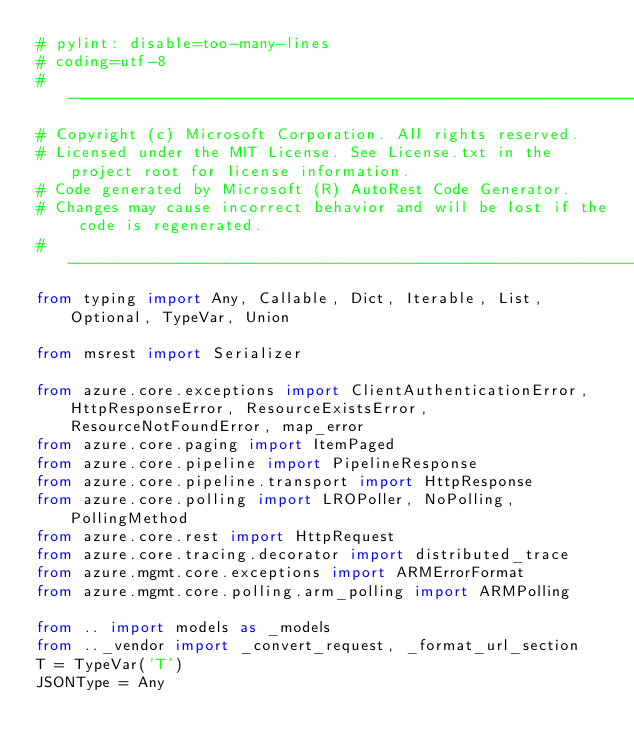<code> <loc_0><loc_0><loc_500><loc_500><_Python_># pylint: disable=too-many-lines
# coding=utf-8
# --------------------------------------------------------------------------
# Copyright (c) Microsoft Corporation. All rights reserved.
# Licensed under the MIT License. See License.txt in the project root for license information.
# Code generated by Microsoft (R) AutoRest Code Generator.
# Changes may cause incorrect behavior and will be lost if the code is regenerated.
# --------------------------------------------------------------------------
from typing import Any, Callable, Dict, Iterable, List, Optional, TypeVar, Union

from msrest import Serializer

from azure.core.exceptions import ClientAuthenticationError, HttpResponseError, ResourceExistsError, ResourceNotFoundError, map_error
from azure.core.paging import ItemPaged
from azure.core.pipeline import PipelineResponse
from azure.core.pipeline.transport import HttpResponse
from azure.core.polling import LROPoller, NoPolling, PollingMethod
from azure.core.rest import HttpRequest
from azure.core.tracing.decorator import distributed_trace
from azure.mgmt.core.exceptions import ARMErrorFormat
from azure.mgmt.core.polling.arm_polling import ARMPolling

from .. import models as _models
from .._vendor import _convert_request, _format_url_section
T = TypeVar('T')
JSONType = Any</code> 